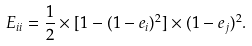Convert formula to latex. <formula><loc_0><loc_0><loc_500><loc_500>E _ { i i } = \frac { 1 } { 2 } \times [ 1 - ( 1 - e _ { i } ) ^ { 2 } ] \times ( 1 - e _ { j } ) ^ { 2 } .</formula> 